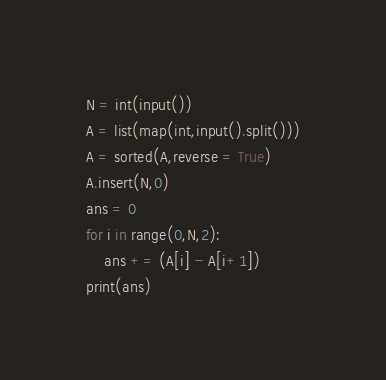<code> <loc_0><loc_0><loc_500><loc_500><_Python_>N = int(input())
A = list(map(int,input().split()))
A = sorted(A,reverse = True)
A.insert(N,0)
ans = 0
for i in range(0,N,2):
	ans += (A[i] - A[i+1])
print(ans)
</code> 